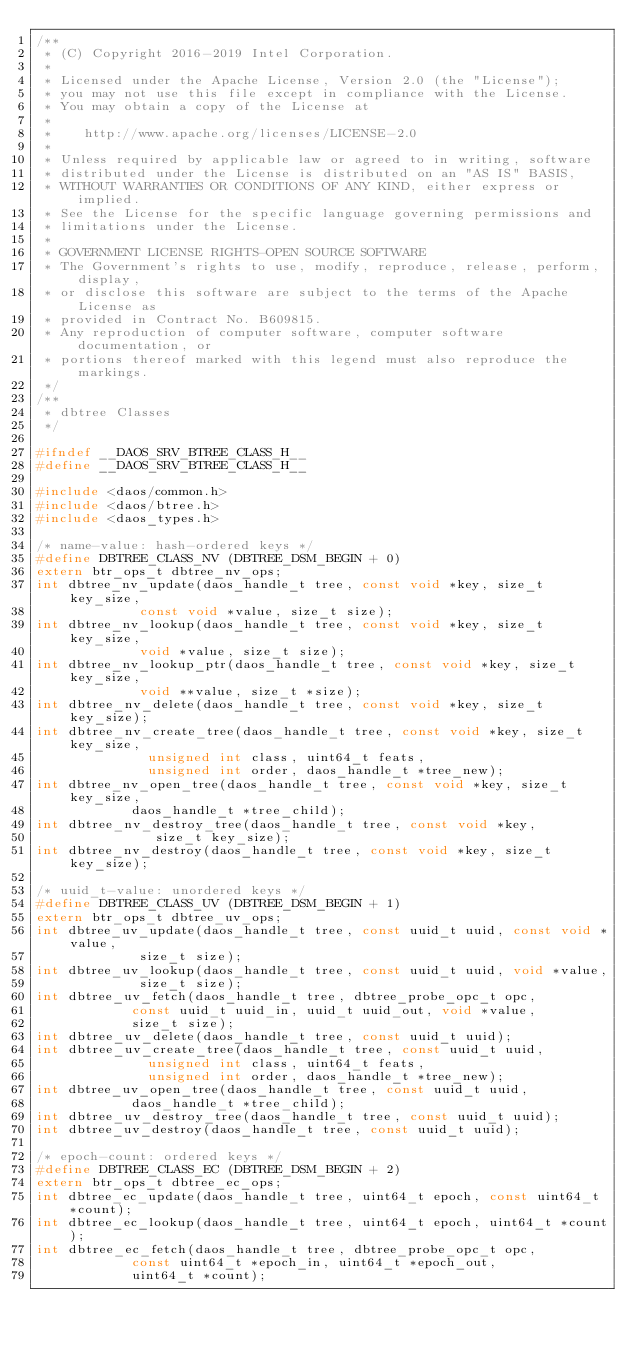<code> <loc_0><loc_0><loc_500><loc_500><_C_>/**
 * (C) Copyright 2016-2019 Intel Corporation.
 *
 * Licensed under the Apache License, Version 2.0 (the "License");
 * you may not use this file except in compliance with the License.
 * You may obtain a copy of the License at
 *
 *    http://www.apache.org/licenses/LICENSE-2.0
 *
 * Unless required by applicable law or agreed to in writing, software
 * distributed under the License is distributed on an "AS IS" BASIS,
 * WITHOUT WARRANTIES OR CONDITIONS OF ANY KIND, either express or implied.
 * See the License for the specific language governing permissions and
 * limitations under the License.
 *
 * GOVERNMENT LICENSE RIGHTS-OPEN SOURCE SOFTWARE
 * The Government's rights to use, modify, reproduce, release, perform, display,
 * or disclose this software are subject to the terms of the Apache License as
 * provided in Contract No. B609815.
 * Any reproduction of computer software, computer software documentation, or
 * portions thereof marked with this legend must also reproduce the markings.
 */
/**
 * dbtree Classes
 */

#ifndef __DAOS_SRV_BTREE_CLASS_H__
#define __DAOS_SRV_BTREE_CLASS_H__

#include <daos/common.h>
#include <daos/btree.h>
#include <daos_types.h>

/* name-value: hash-ordered keys */
#define DBTREE_CLASS_NV (DBTREE_DSM_BEGIN + 0)
extern btr_ops_t dbtree_nv_ops;
int dbtree_nv_update(daos_handle_t tree, const void *key, size_t key_size,
		     const void *value, size_t size);
int dbtree_nv_lookup(daos_handle_t tree, const void *key, size_t key_size,
		     void *value, size_t size);
int dbtree_nv_lookup_ptr(daos_handle_t tree, const void *key, size_t key_size,
			 void **value, size_t *size);
int dbtree_nv_delete(daos_handle_t tree, const void *key, size_t key_size);
int dbtree_nv_create_tree(daos_handle_t tree, const void *key, size_t key_size,
			  unsigned int class, uint64_t feats,
			  unsigned int order, daos_handle_t *tree_new);
int dbtree_nv_open_tree(daos_handle_t tree, const void *key, size_t key_size,
			daos_handle_t *tree_child);
int dbtree_nv_destroy_tree(daos_handle_t tree, const void *key,
			   size_t key_size);
int dbtree_nv_destroy(daos_handle_t tree, const void *key, size_t key_size);

/* uuid_t-value: unordered keys */
#define DBTREE_CLASS_UV (DBTREE_DSM_BEGIN + 1)
extern btr_ops_t dbtree_uv_ops;
int dbtree_uv_update(daos_handle_t tree, const uuid_t uuid, const void *value,
		     size_t size);
int dbtree_uv_lookup(daos_handle_t tree, const uuid_t uuid, void *value,
		     size_t size);
int dbtree_uv_fetch(daos_handle_t tree, dbtree_probe_opc_t opc,
		    const uuid_t uuid_in, uuid_t uuid_out, void *value,
		    size_t size);
int dbtree_uv_delete(daos_handle_t tree, const uuid_t uuid);
int dbtree_uv_create_tree(daos_handle_t tree, const uuid_t uuid,
			  unsigned int class, uint64_t feats,
			  unsigned int order, daos_handle_t *tree_new);
int dbtree_uv_open_tree(daos_handle_t tree, const uuid_t uuid,
			daos_handle_t *tree_child);
int dbtree_uv_destroy_tree(daos_handle_t tree, const uuid_t uuid);
int dbtree_uv_destroy(daos_handle_t tree, const uuid_t uuid);

/* epoch-count: ordered keys */
#define DBTREE_CLASS_EC (DBTREE_DSM_BEGIN + 2)
extern btr_ops_t dbtree_ec_ops;
int dbtree_ec_update(daos_handle_t tree, uint64_t epoch, const uint64_t *count);
int dbtree_ec_lookup(daos_handle_t tree, uint64_t epoch, uint64_t *count);
int dbtree_ec_fetch(daos_handle_t tree, dbtree_probe_opc_t opc,
		    const uint64_t *epoch_in, uint64_t *epoch_out,
		    uint64_t *count);</code> 